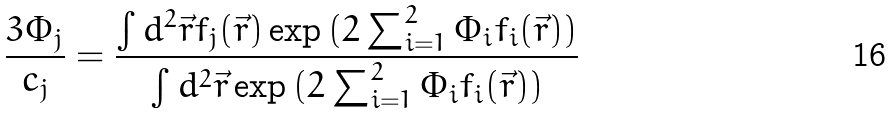<formula> <loc_0><loc_0><loc_500><loc_500>\frac { 3 \Phi _ { j } } { c _ { j } } = \frac { \int d ^ { 2 } \vec { r } f _ { j } ( \vec { r } ) \exp { ( 2 \sum _ { i = 1 } ^ { 2 } \Phi _ { i } f _ { i } ( \vec { r } ) ) } } { \int d ^ { 2 } \vec { r } \exp { ( 2 \sum _ { i = 1 } ^ { 2 } \Phi _ { i } f _ { i } ( \vec { r } ) ) } }</formula> 